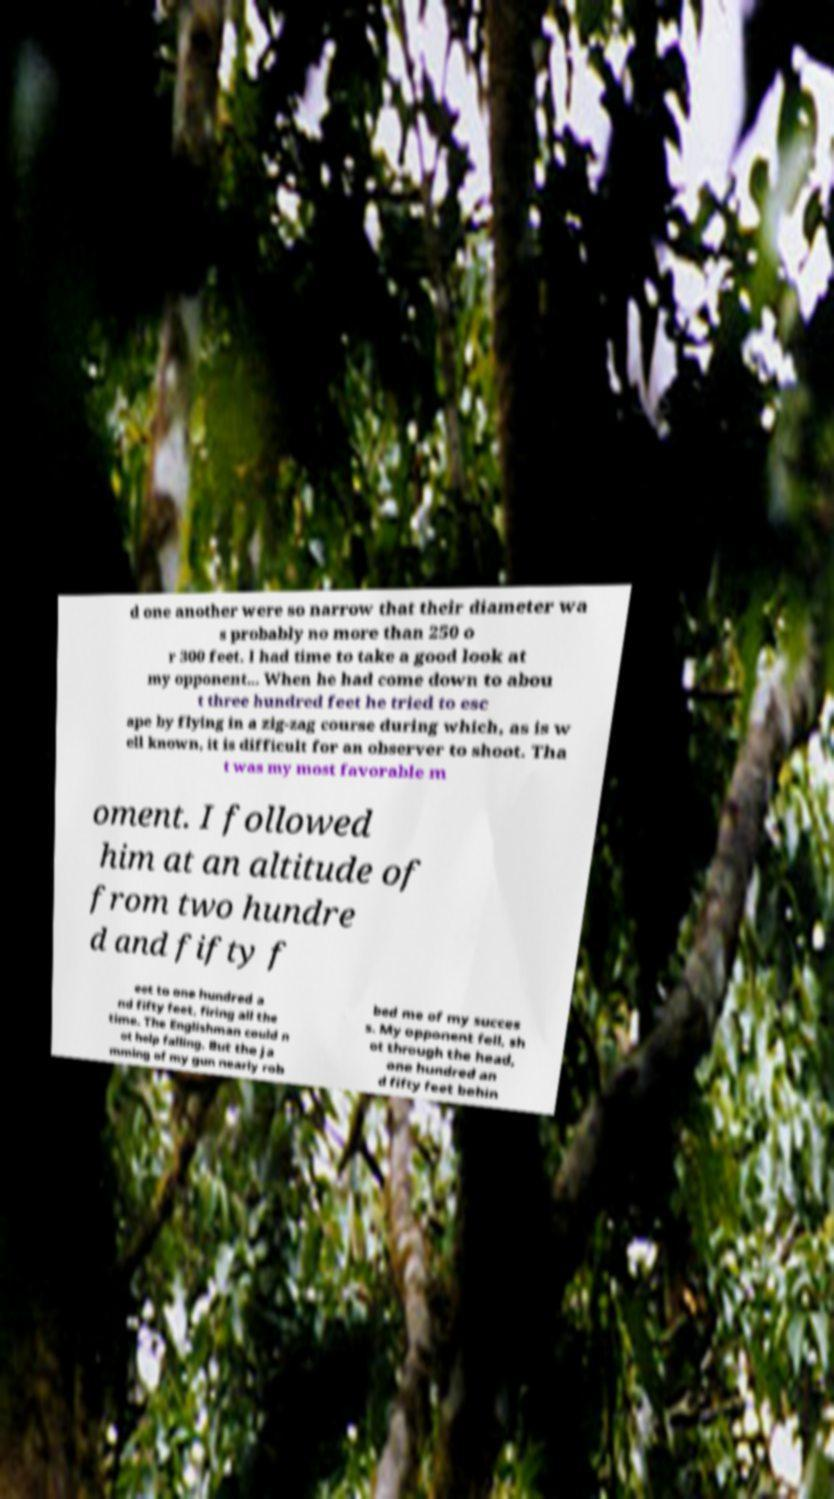Could you assist in decoding the text presented in this image and type it out clearly? d one another were so narrow that their diameter wa s probably no more than 250 o r 300 feet. I had time to take a good look at my opponent... When he had come down to abou t three hundred feet he tried to esc ape by flying in a zig-zag course during which, as is w ell known, it is difficult for an observer to shoot. Tha t was my most favorable m oment. I followed him at an altitude of from two hundre d and fifty f eet to one hundred a nd fifty feet, firing all the time. The Englishman could n ot help falling. But the ja mming of my gun nearly rob bed me of my succes s. My opponent fell, sh ot through the head, one hundred an d fifty feet behin 